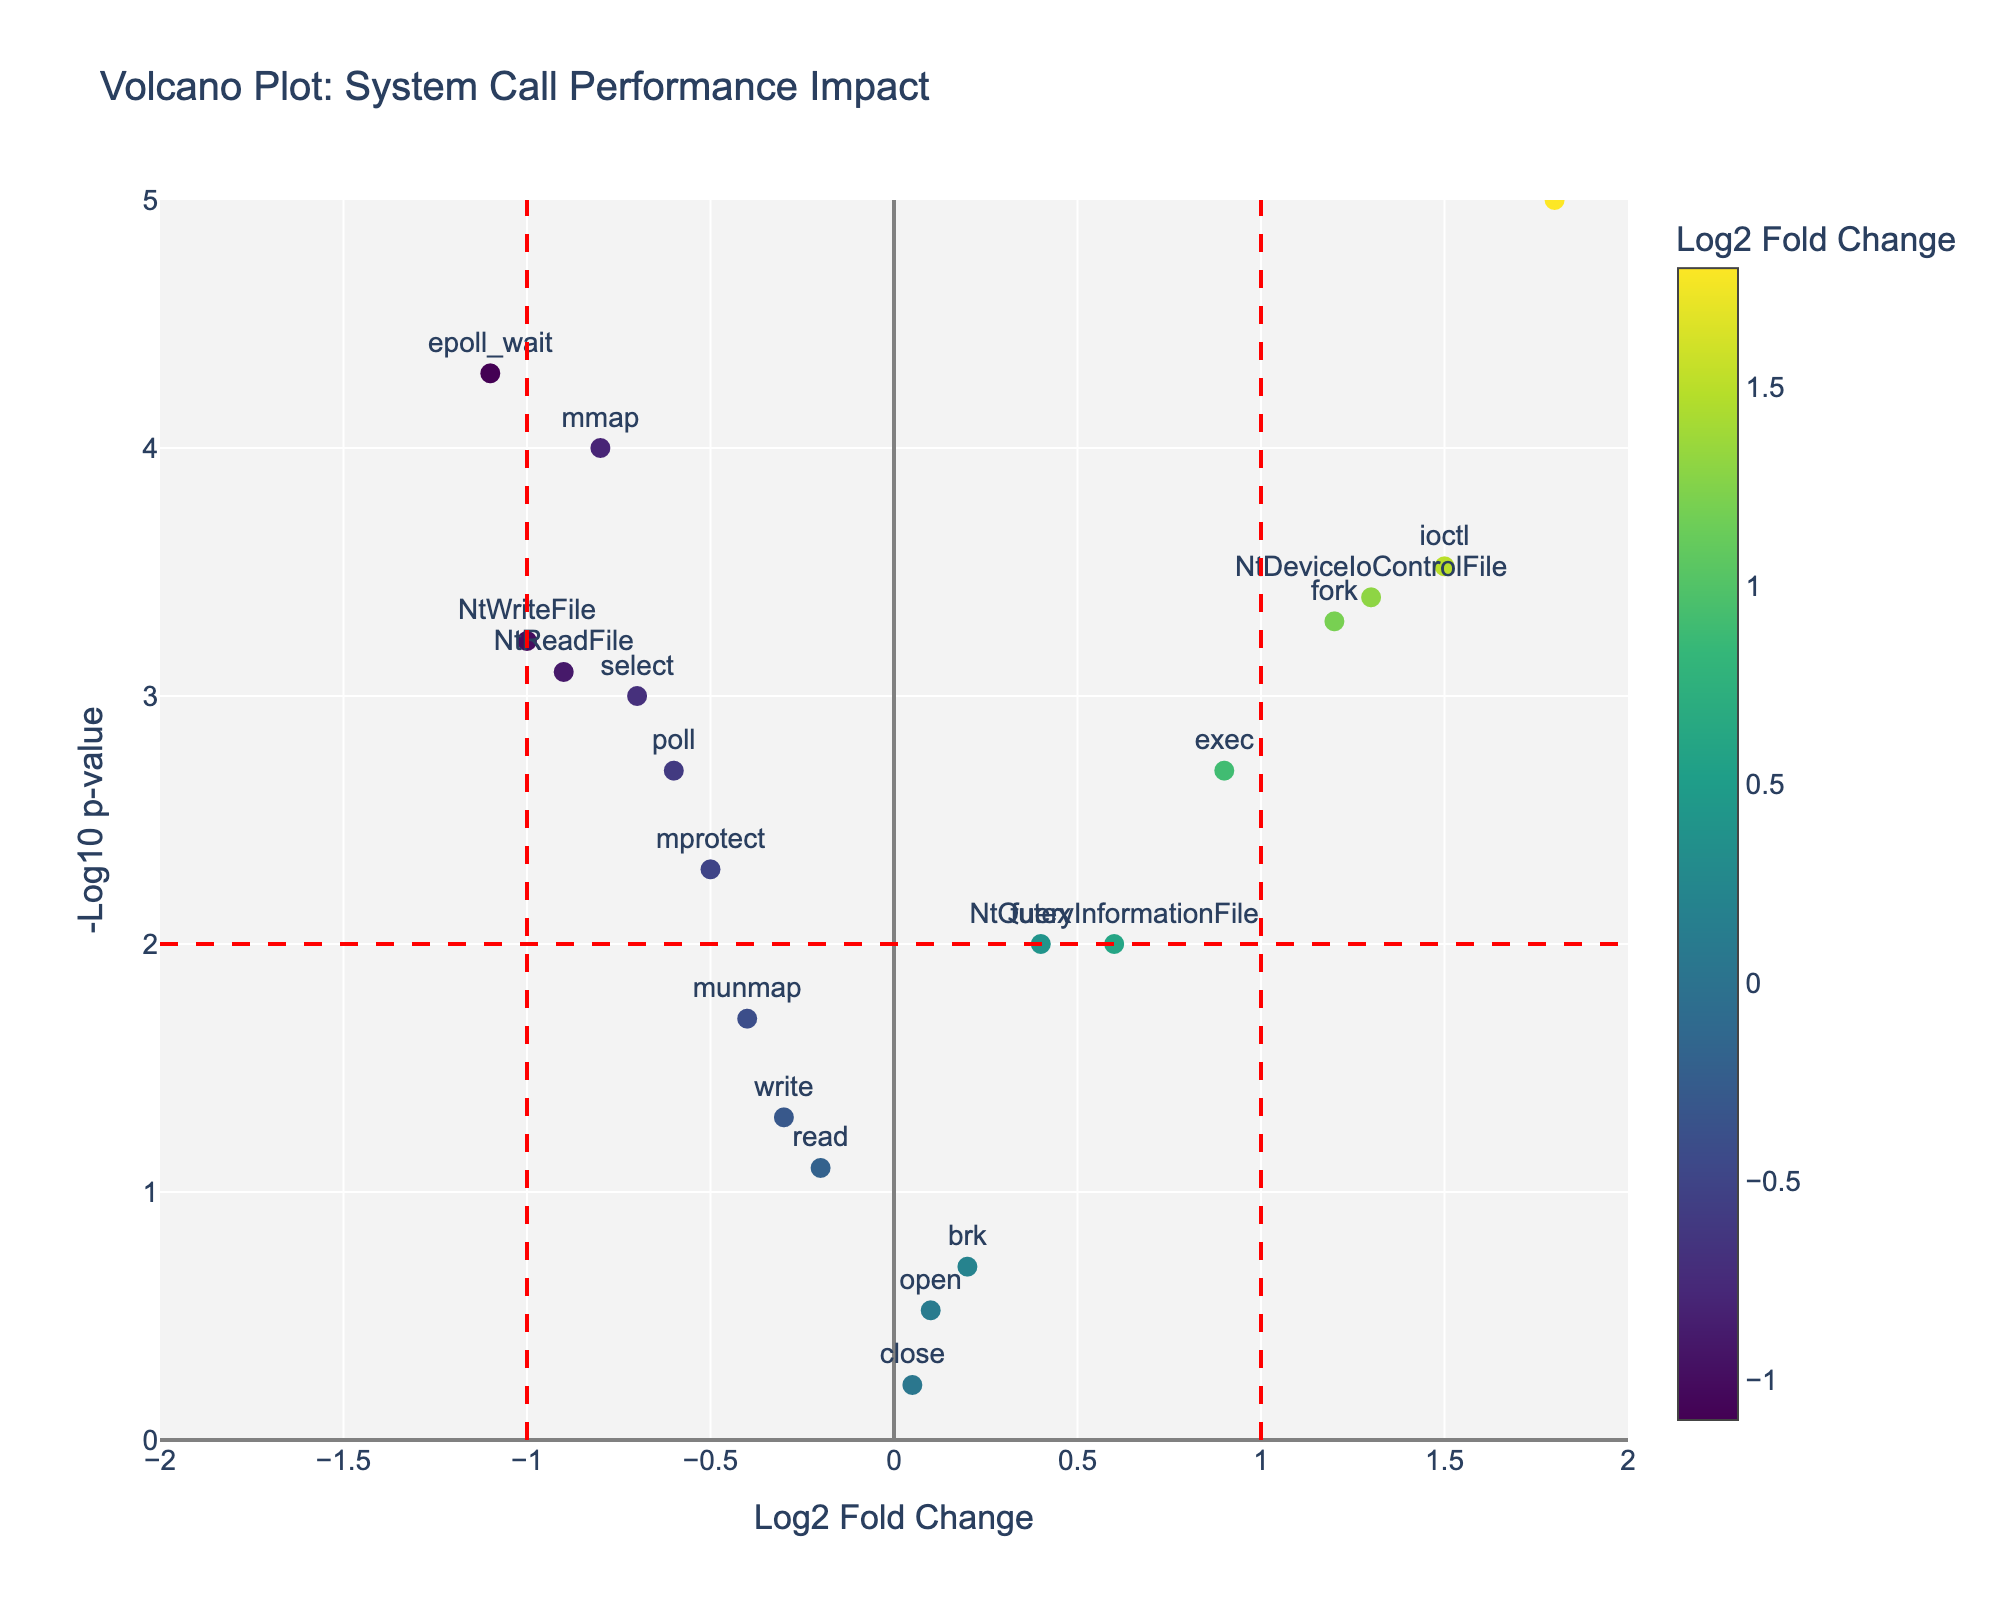What is the title of the plot? The title is located at the top of the figure, usually describing the main subject of the plot. Here, it reads "Volcano Plot: System Call Performance Impact".
Answer: Volcano Plot: System Call Performance Impact What does the x-axis represent in this plot? The x-axis of a volcano plot typically represents the log2 fold change, which indicates the magnitude of change (up or down) in performance for the system calls.
Answer: Log2 Fold Change What system call has the highest -log10 p-value? To find the system call with the highest -log10 p-value, look for the point that is highest on the y-axis. The label for this point is "NtCreateFile".
Answer: NtCreateFile Which system call has the lowest log2 fold change? The system call with the lowest log2 fold change is the point furthest to the left on the x-axis, which is "epoll_wait".
Answer: epoll_wait How many system calls have a log2 fold change greater than 1? By visually inspecting the plot for points with a log2 fold change greater than 1 on the x-axis and counting them, we find there are three such points: "fork", "ioctl", and "NtDeviceIoControlFile".
Answer: 3 What are the log2 fold change and p-value of the system call "mmap"? Visually locate the "mmap" point on the plot and refer to the hoverinfo. It shows a log2 fold change of -0.8 and a p-value of 0.0001.
Answer: Log2 Fold Change: -0.8, p-value: 0.0001 Which system call lies closest to the origin (0,0)? The point closest to the origin can be found by checking the proximity of points to (0,0). The "close" system call is nearest to the origin.
Answer: close Compare the log2 fold change of "NtCreateFile" and "NtWriteFile". Which one is greater? By comparing the x-axis positions, "NtCreateFile" has a log2 fold change of 1.8, and "NtWriteFile" has -1.0. Hence, "NtCreateFile" has the greater log2 fold change.
Answer: NtCreateFile Which system call has the smallest p-value and what is it? The system call with the smallest p-value will be the point with the largest -log10 p-value. "NtCreateFile" has the smallest p-value of 0.00001.
Answer: NtCreateFile, 0.00001 What is the range of -log10 p-values present in the plot? To determine the range, observe the maximum and minimum points on the y-axis. The range is from 0 (for more insignificant p-values) to around 5 (for the smallest p-values).
Answer: 0 to 5 